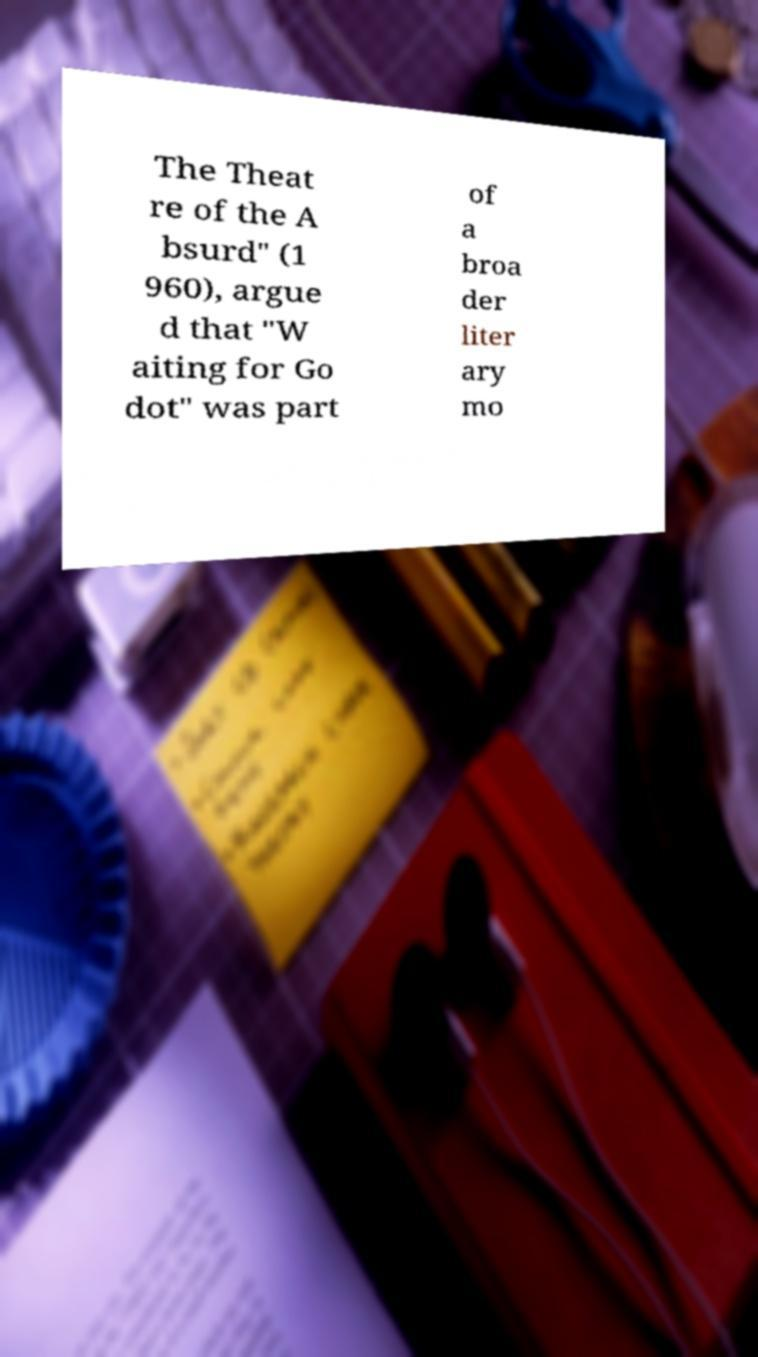I need the written content from this picture converted into text. Can you do that? The Theat re of the A bsurd" (1 960), argue d that "W aiting for Go dot" was part of a broa der liter ary mo 